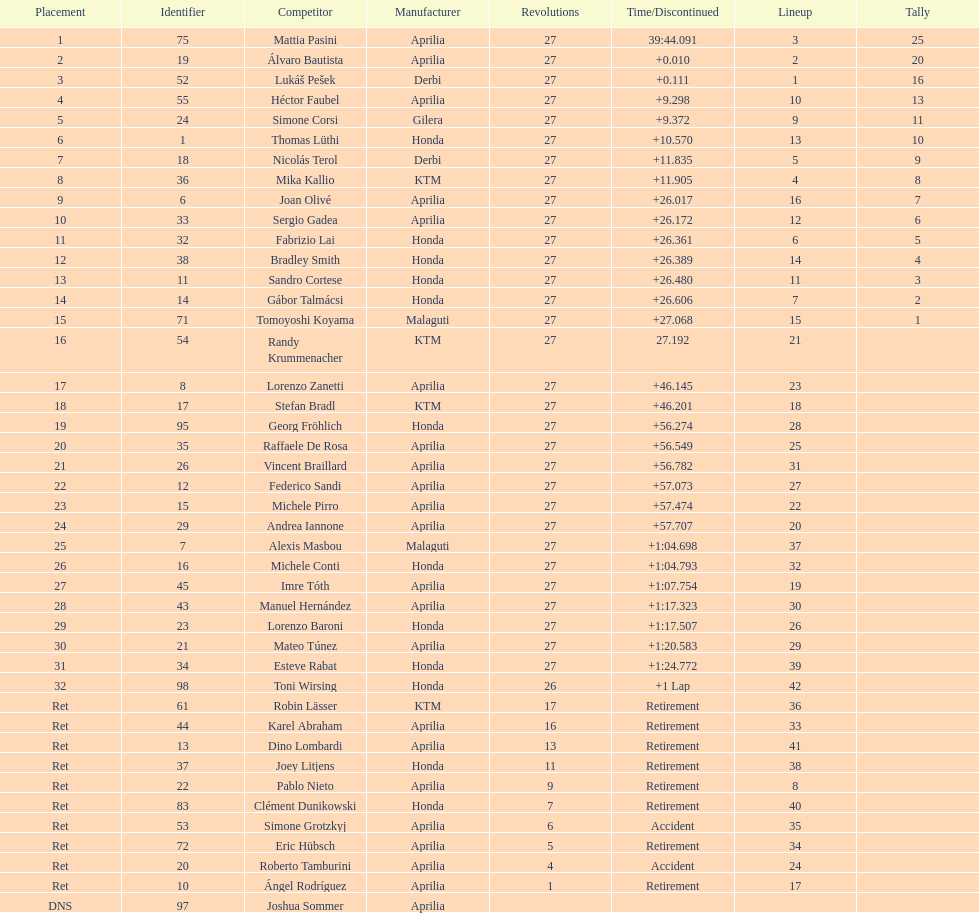Would you be able to parse every entry in this table? {'header': ['Placement', 'Identifier', 'Competitor', 'Manufacturer', 'Revolutions', 'Time/Discontinued', 'Lineup', 'Tally'], 'rows': [['1', '75', 'Mattia Pasini', 'Aprilia', '27', '39:44.091', '3', '25'], ['2', '19', 'Álvaro Bautista', 'Aprilia', '27', '+0.010', '2', '20'], ['3', '52', 'Lukáš Pešek', 'Derbi', '27', '+0.111', '1', '16'], ['4', '55', 'Héctor Faubel', 'Aprilia', '27', '+9.298', '10', '13'], ['5', '24', 'Simone Corsi', 'Gilera', '27', '+9.372', '9', '11'], ['6', '1', 'Thomas Lüthi', 'Honda', '27', '+10.570', '13', '10'], ['7', '18', 'Nicolás Terol', 'Derbi', '27', '+11.835', '5', '9'], ['8', '36', 'Mika Kallio', 'KTM', '27', '+11.905', '4', '8'], ['9', '6', 'Joan Olivé', 'Aprilia', '27', '+26.017', '16', '7'], ['10', '33', 'Sergio Gadea', 'Aprilia', '27', '+26.172', '12', '6'], ['11', '32', 'Fabrizio Lai', 'Honda', '27', '+26.361', '6', '5'], ['12', '38', 'Bradley Smith', 'Honda', '27', '+26.389', '14', '4'], ['13', '11', 'Sandro Cortese', 'Honda', '27', '+26.480', '11', '3'], ['14', '14', 'Gábor Talmácsi', 'Honda', '27', '+26.606', '7', '2'], ['15', '71', 'Tomoyoshi Koyama', 'Malaguti', '27', '+27.068', '15', '1'], ['16', '54', 'Randy Krummenacher', 'KTM', '27', '27.192', '21', ''], ['17', '8', 'Lorenzo Zanetti', 'Aprilia', '27', '+46.145', '23', ''], ['18', '17', 'Stefan Bradl', 'KTM', '27', '+46.201', '18', ''], ['19', '95', 'Georg Fröhlich', 'Honda', '27', '+56.274', '28', ''], ['20', '35', 'Raffaele De Rosa', 'Aprilia', '27', '+56.549', '25', ''], ['21', '26', 'Vincent Braillard', 'Aprilia', '27', '+56.782', '31', ''], ['22', '12', 'Federico Sandi', 'Aprilia', '27', '+57.073', '27', ''], ['23', '15', 'Michele Pirro', 'Aprilia', '27', '+57.474', '22', ''], ['24', '29', 'Andrea Iannone', 'Aprilia', '27', '+57.707', '20', ''], ['25', '7', 'Alexis Masbou', 'Malaguti', '27', '+1:04.698', '37', ''], ['26', '16', 'Michele Conti', 'Honda', '27', '+1:04.793', '32', ''], ['27', '45', 'Imre Tóth', 'Aprilia', '27', '+1:07.754', '19', ''], ['28', '43', 'Manuel Hernández', 'Aprilia', '27', '+1:17.323', '30', ''], ['29', '23', 'Lorenzo Baroni', 'Honda', '27', '+1:17.507', '26', ''], ['30', '21', 'Mateo Túnez', 'Aprilia', '27', '+1:20.583', '29', ''], ['31', '34', 'Esteve Rabat', 'Honda', '27', '+1:24.772', '39', ''], ['32', '98', 'Toni Wirsing', 'Honda', '26', '+1 Lap', '42', ''], ['Ret', '61', 'Robin Lässer', 'KTM', '17', 'Retirement', '36', ''], ['Ret', '44', 'Karel Abraham', 'Aprilia', '16', 'Retirement', '33', ''], ['Ret', '13', 'Dino Lombardi', 'Aprilia', '13', 'Retirement', '41', ''], ['Ret', '37', 'Joey Litjens', 'Honda', '11', 'Retirement', '38', ''], ['Ret', '22', 'Pablo Nieto', 'Aprilia', '9', 'Retirement', '8', ''], ['Ret', '83', 'Clément Dunikowski', 'Honda', '7', 'Retirement', '40', ''], ['Ret', '53', 'Simone Grotzkyj', 'Aprilia', '6', 'Accident', '35', ''], ['Ret', '72', 'Eric Hübsch', 'Aprilia', '5', 'Retirement', '34', ''], ['Ret', '20', 'Roberto Tamburini', 'Aprilia', '4', 'Accident', '24', ''], ['Ret', '10', 'Ángel Rodríguez', 'Aprilia', '1', 'Retirement', '17', ''], ['DNS', '97', 'Joshua Sommer', 'Aprilia', '', '', '', '']]} What was the total number of positions in the 125cc classification? 43. 